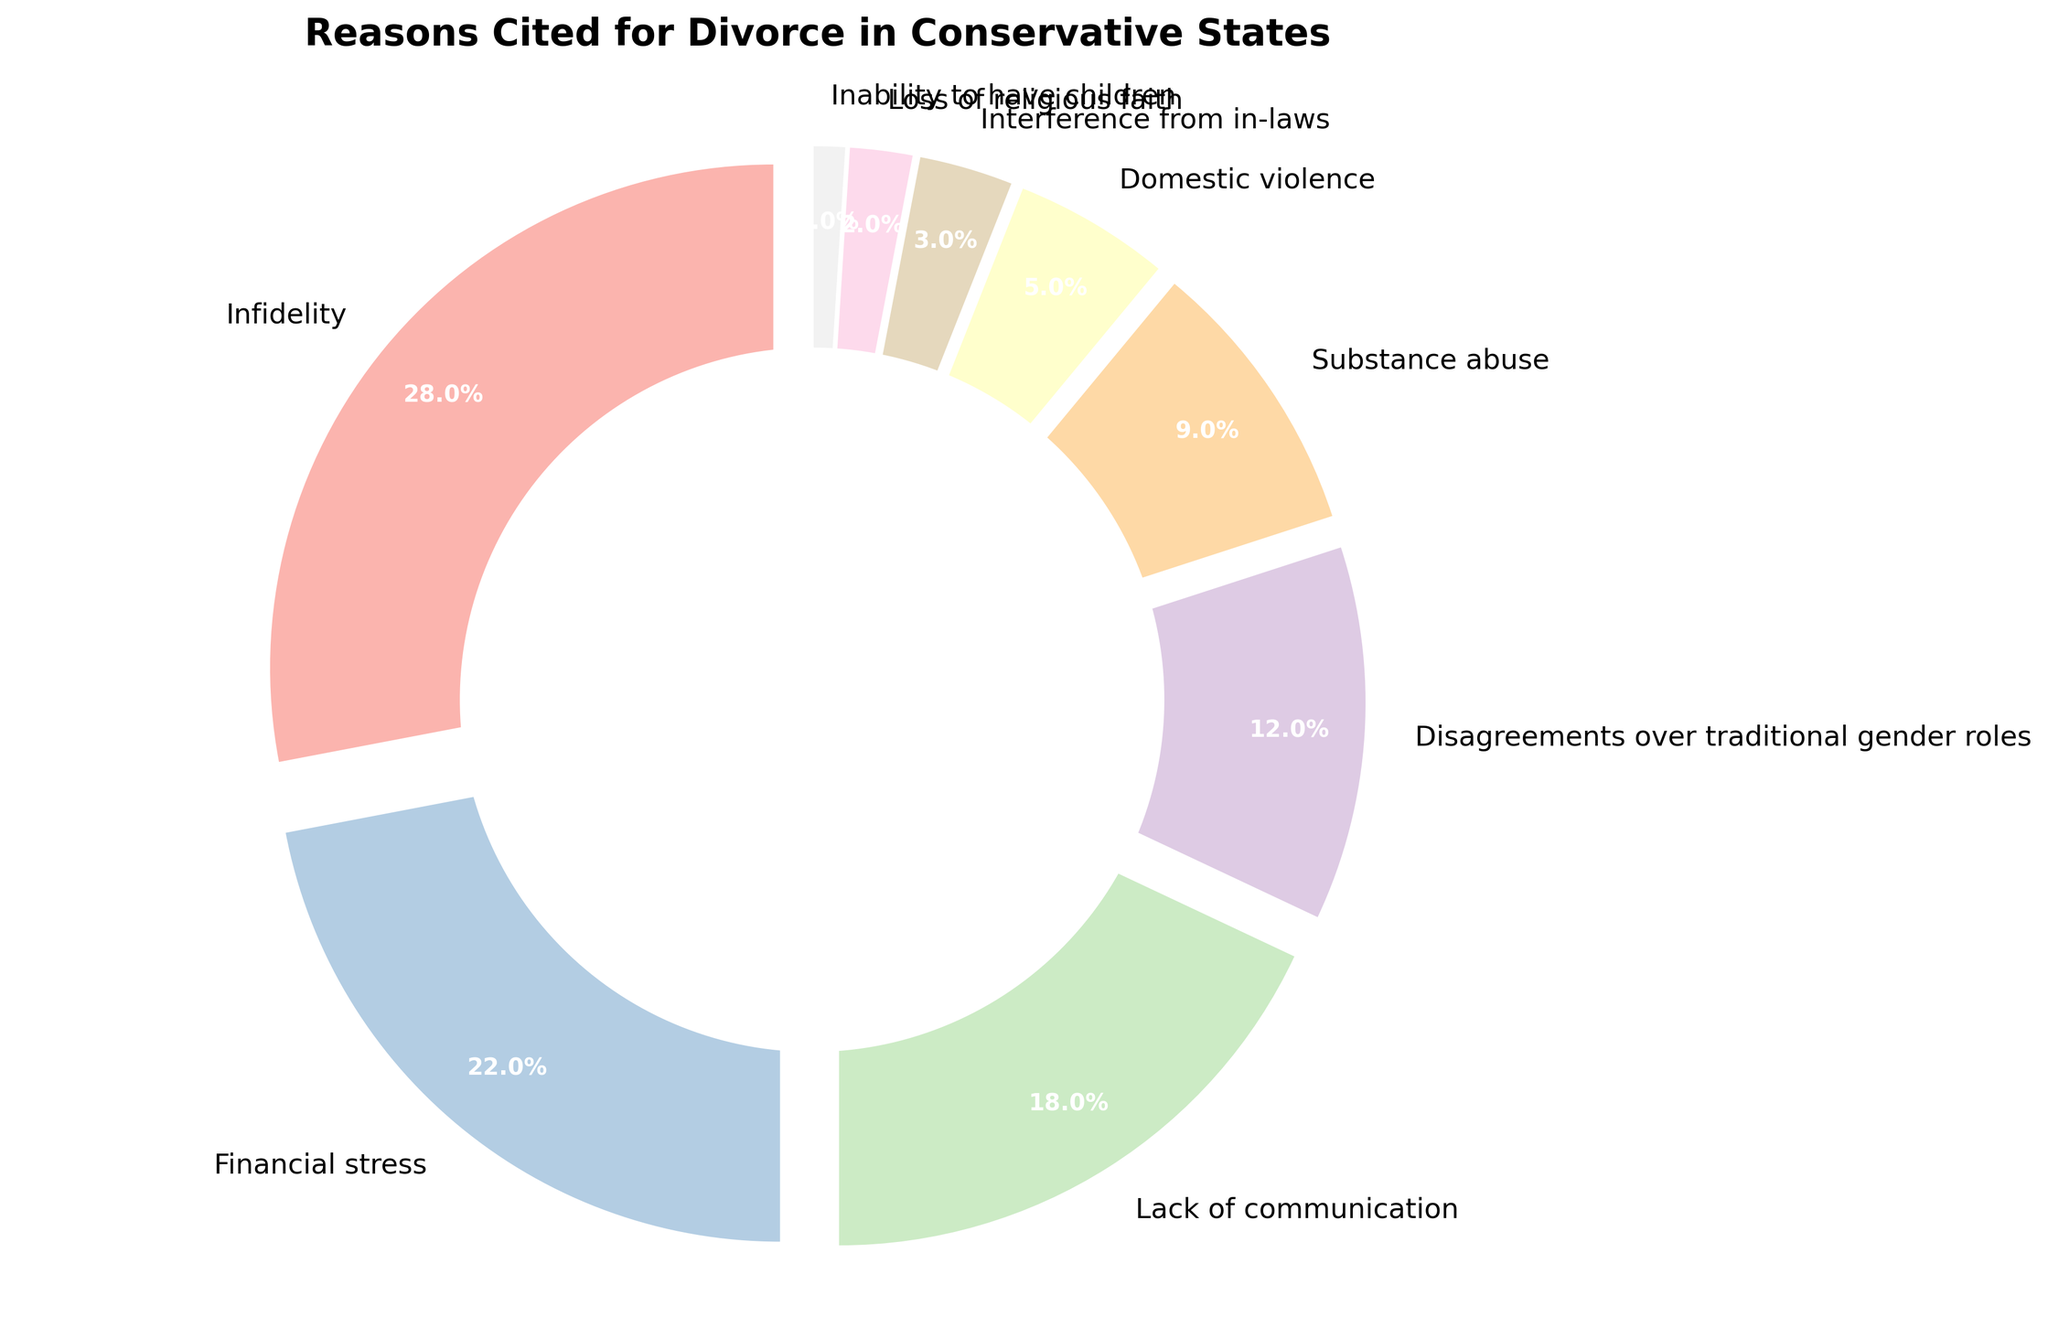which reason cited for divorce has the largest percentage? The pie chart shows that Infidelity has the largest slice, representing 28%.
Answer: Infidelity According to the chart, what is the combined percentage of financial stress and lack of communication? Financial stress has a percentage of 22% and lack of communication has 18%. Adding these together: 22% + 18% = 40%.
Answer: 40% Which two reasons have the smallest percentages? According to the pie chart, Loss of religious faith (2%) and Inability to have children (1%) occupy the smallest slices.
Answer: Loss of religious faith and Inability to have children Is the percentage of disagreements over traditional gender roles greater or lesser than the percentage of substance abuse? Disagreements over traditional gender roles have a percentage of 12%, whereas substance abuse has 9%. Since 12% is greater than 9%, disagreements over traditional gender roles have a higher percentage.
Answer: Greater What percentage of reasons cited for divorce are attributed to domestic violence and interference from in-laws combined? The pie chart shows domestic violence at 5% and interference from in-laws at 3%. Adding these together gives: 5% + 3% = 8%.
Answer: 8% What is the most frequently cited reason avoiding traditional family roles? The pie chart lists disagreements over traditional gender roles at 12%, indicating it is cited with notable frequency but is not the most frequent reason overall.
Answer: Disagreements over traditional gender roles By how much does infidelity exceed financial stress as a reason for divorce? Infidelity is cited at 28% while financial stress is at 22%. The difference is: 28% - 22% = 6%.
Answer: 6% Which reasons cited for divorce collectively make up more than 50%? Infidelity (28%), financial stress (22%), and lack of communication (18%) add up to 28% + 22% + 18% = 68%, which is more than 50%.
Answer: Infidelity, financial stress, and lack of communication If you combine the reasons from the chart that are traditionally associated with family values, what is the total percentage? Disagreements over traditional gender roles (12%), loss of religious faith (2%), and interference from in-laws (3%) together make: 12% + 2% + 3% = 17%.
Answer: 17% 